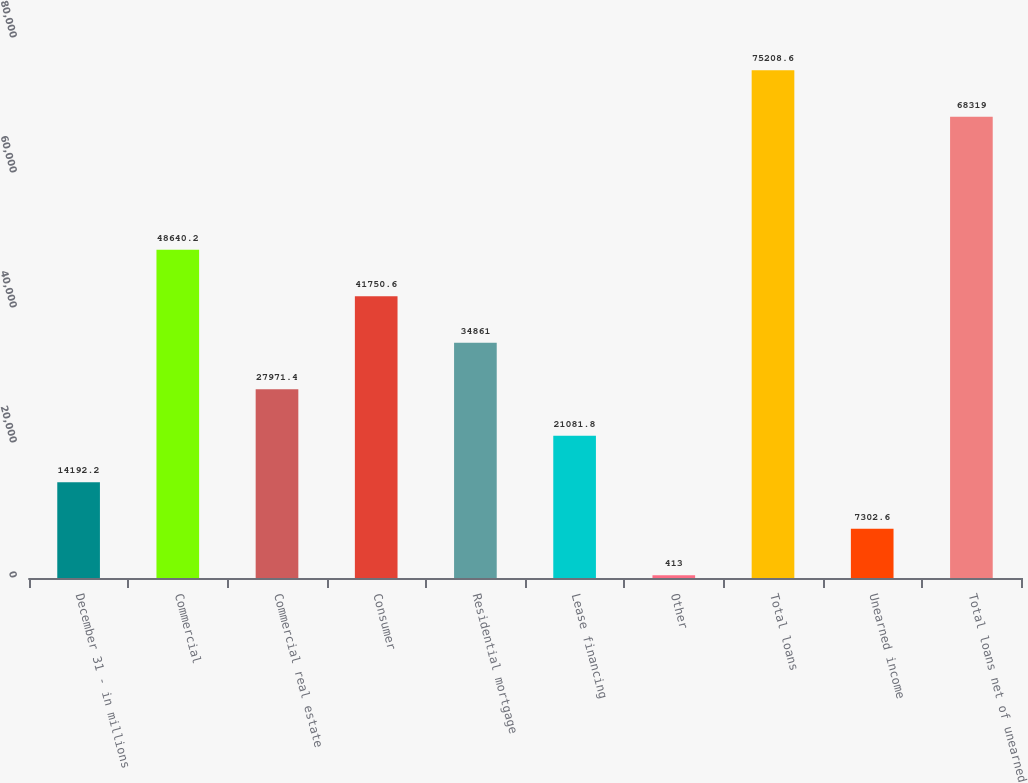Convert chart. <chart><loc_0><loc_0><loc_500><loc_500><bar_chart><fcel>December 31 - in millions<fcel>Commercial<fcel>Commercial real estate<fcel>Consumer<fcel>Residential mortgage<fcel>Lease financing<fcel>Other<fcel>Total loans<fcel>Unearned income<fcel>Total loans net of unearned<nl><fcel>14192.2<fcel>48640.2<fcel>27971.4<fcel>41750.6<fcel>34861<fcel>21081.8<fcel>413<fcel>75208.6<fcel>7302.6<fcel>68319<nl></chart> 